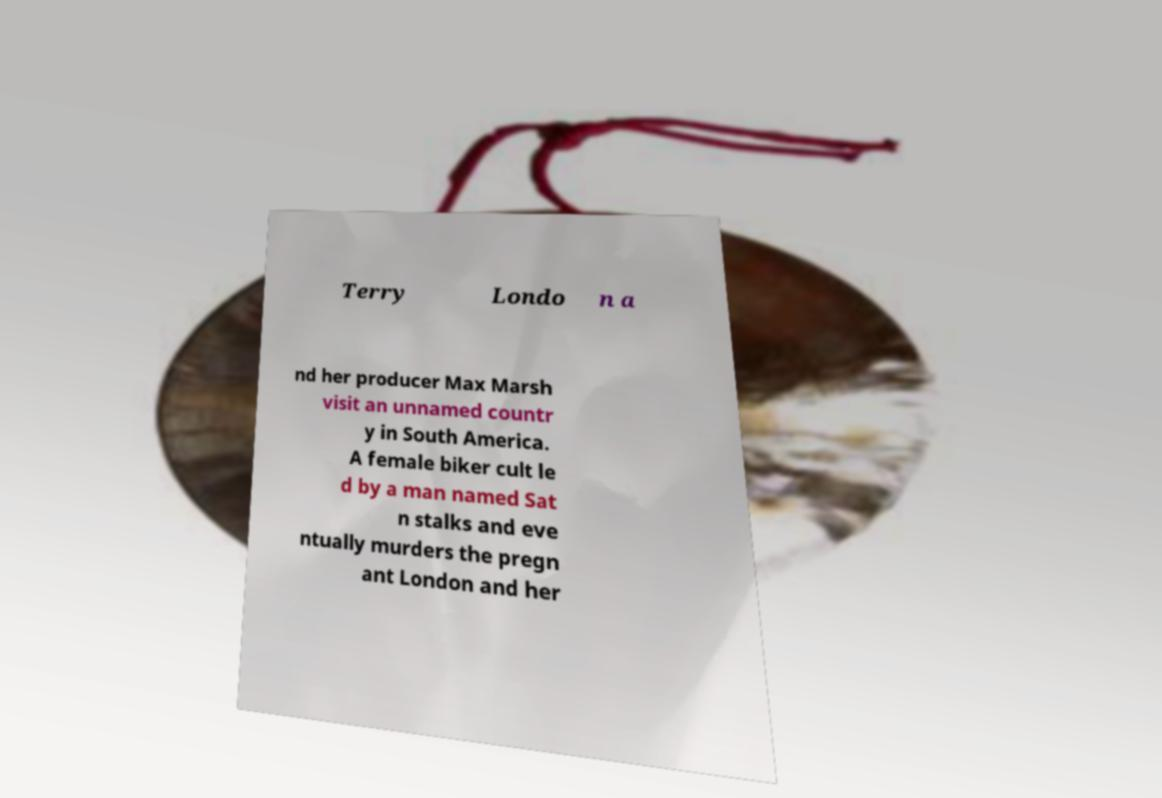Please identify and transcribe the text found in this image. Terry Londo n a nd her producer Max Marsh visit an unnamed countr y in South America. A female biker cult le d by a man named Sat n stalks and eve ntually murders the pregn ant London and her 